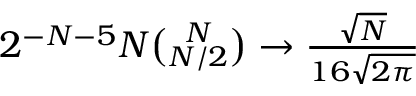<formula> <loc_0><loc_0><loc_500><loc_500>\begin{array} { r } { 2 ^ { - N - 5 } N \binom { N } { N / 2 } \to \frac { \sqrt { N } } { 1 6 \sqrt { 2 \pi } } } \end{array}</formula> 